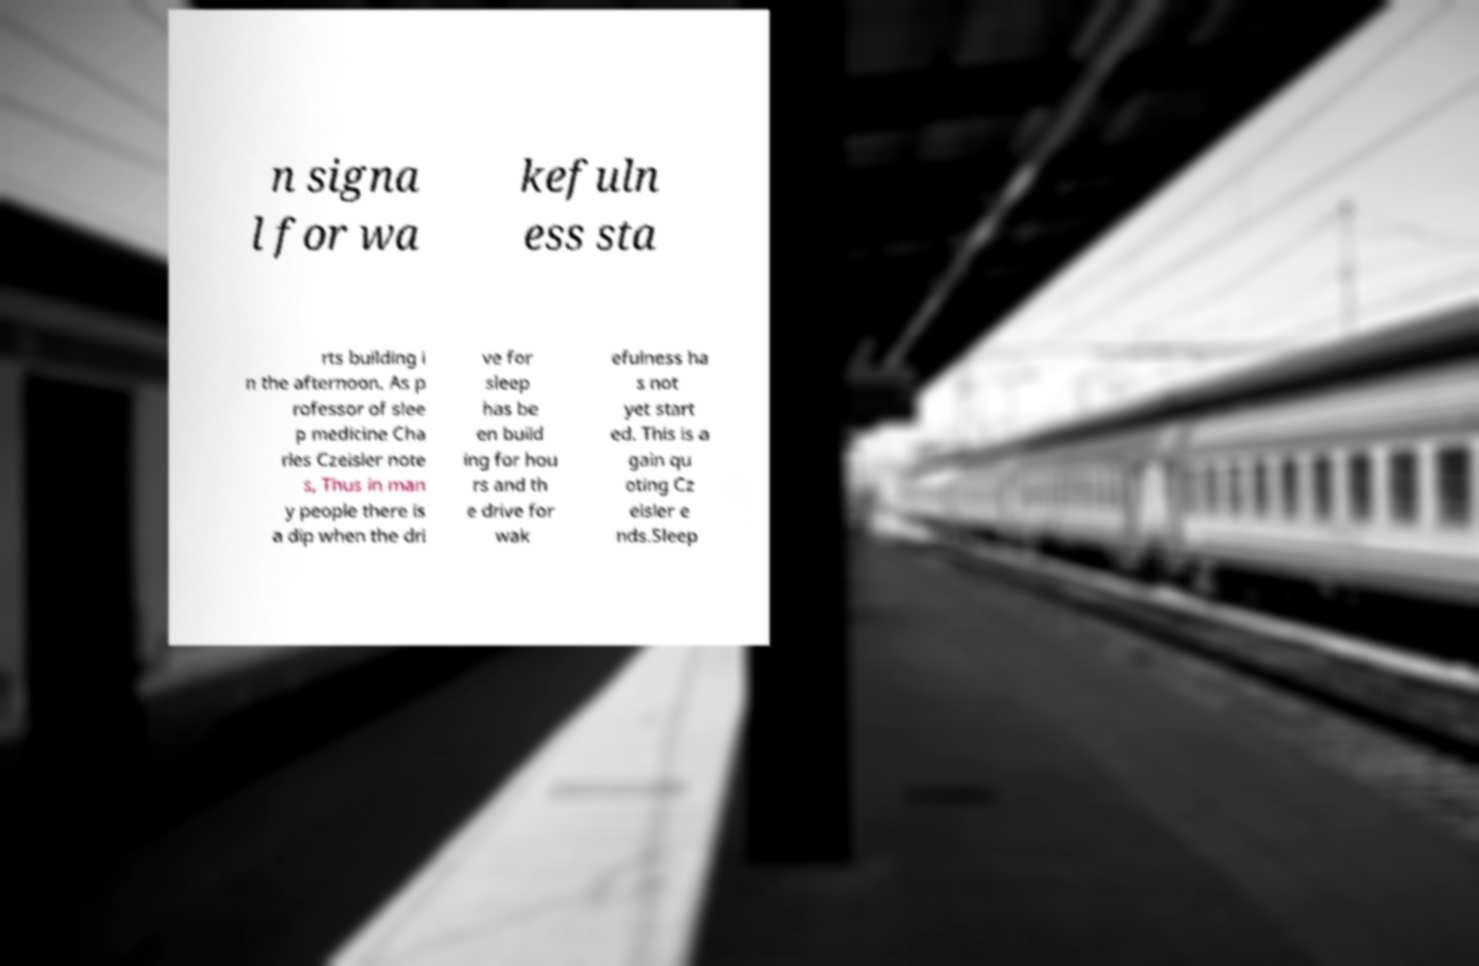Please read and relay the text visible in this image. What does it say? n signa l for wa kefuln ess sta rts building i n the afternoon. As p rofessor of slee p medicine Cha rles Czeisler note s, Thus in man y people there is a dip when the dri ve for sleep has be en build ing for hou rs and th e drive for wak efulness ha s not yet start ed. This is a gain qu oting Cz eisler e nds.Sleep 